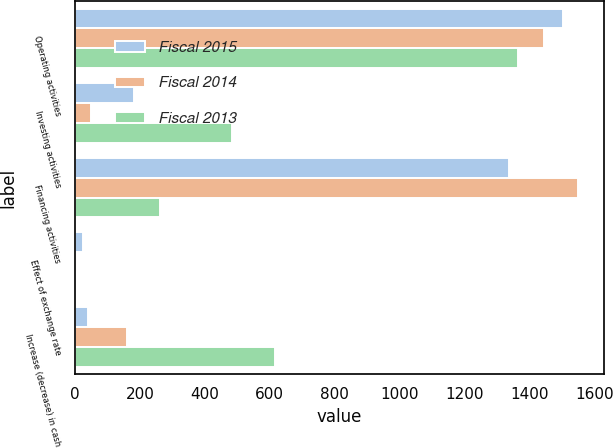Convert chart. <chart><loc_0><loc_0><loc_500><loc_500><stacked_bar_chart><ecel><fcel>Operating activities<fcel>Investing activities<fcel>Financing activities<fcel>Effect of exchange rate<fcel>Increase (decrease) in cash<nl><fcel>Fiscal 2015<fcel>1504<fcel>182<fcel>1337<fcel>26<fcel>41<nl><fcel>Fiscal 2014<fcel>1446<fcel>49<fcel>1551<fcel>6<fcel>160<nl><fcel>Fiscal 2013<fcel>1366<fcel>485<fcel>262<fcel>3<fcel>616<nl></chart> 